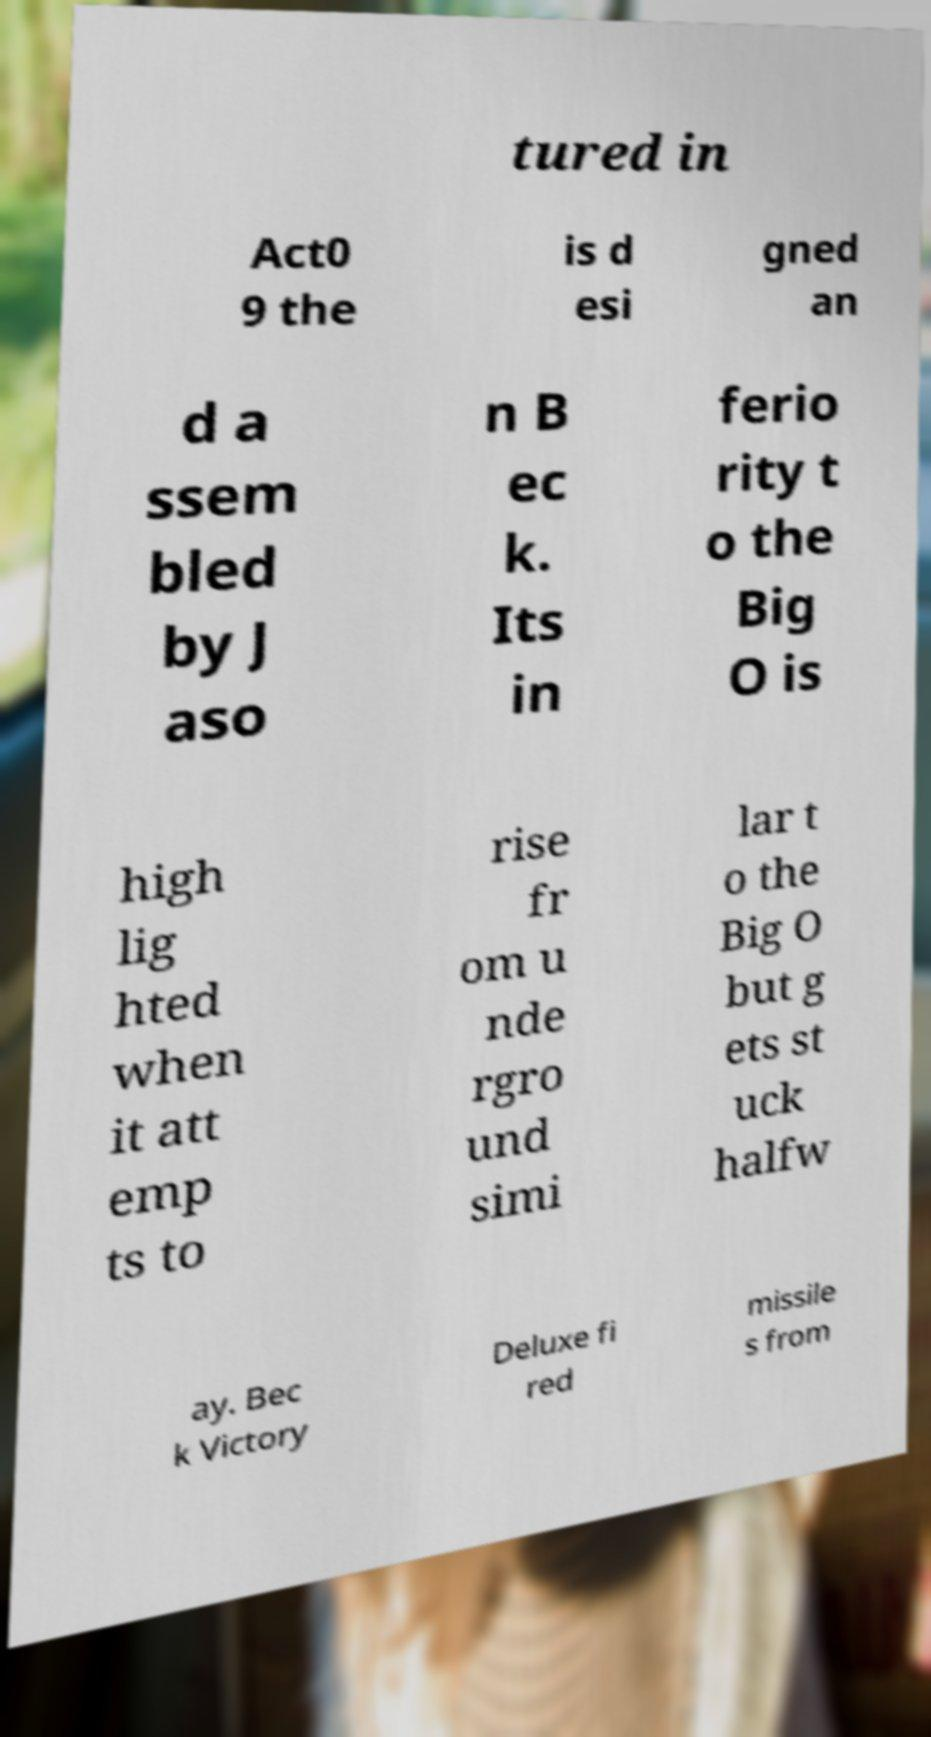There's text embedded in this image that I need extracted. Can you transcribe it verbatim? tured in Act0 9 the is d esi gned an d a ssem bled by J aso n B ec k. Its in ferio rity t o the Big O is high lig hted when it att emp ts to rise fr om u nde rgro und simi lar t o the Big O but g ets st uck halfw ay. Bec k Victory Deluxe fi red missile s from 